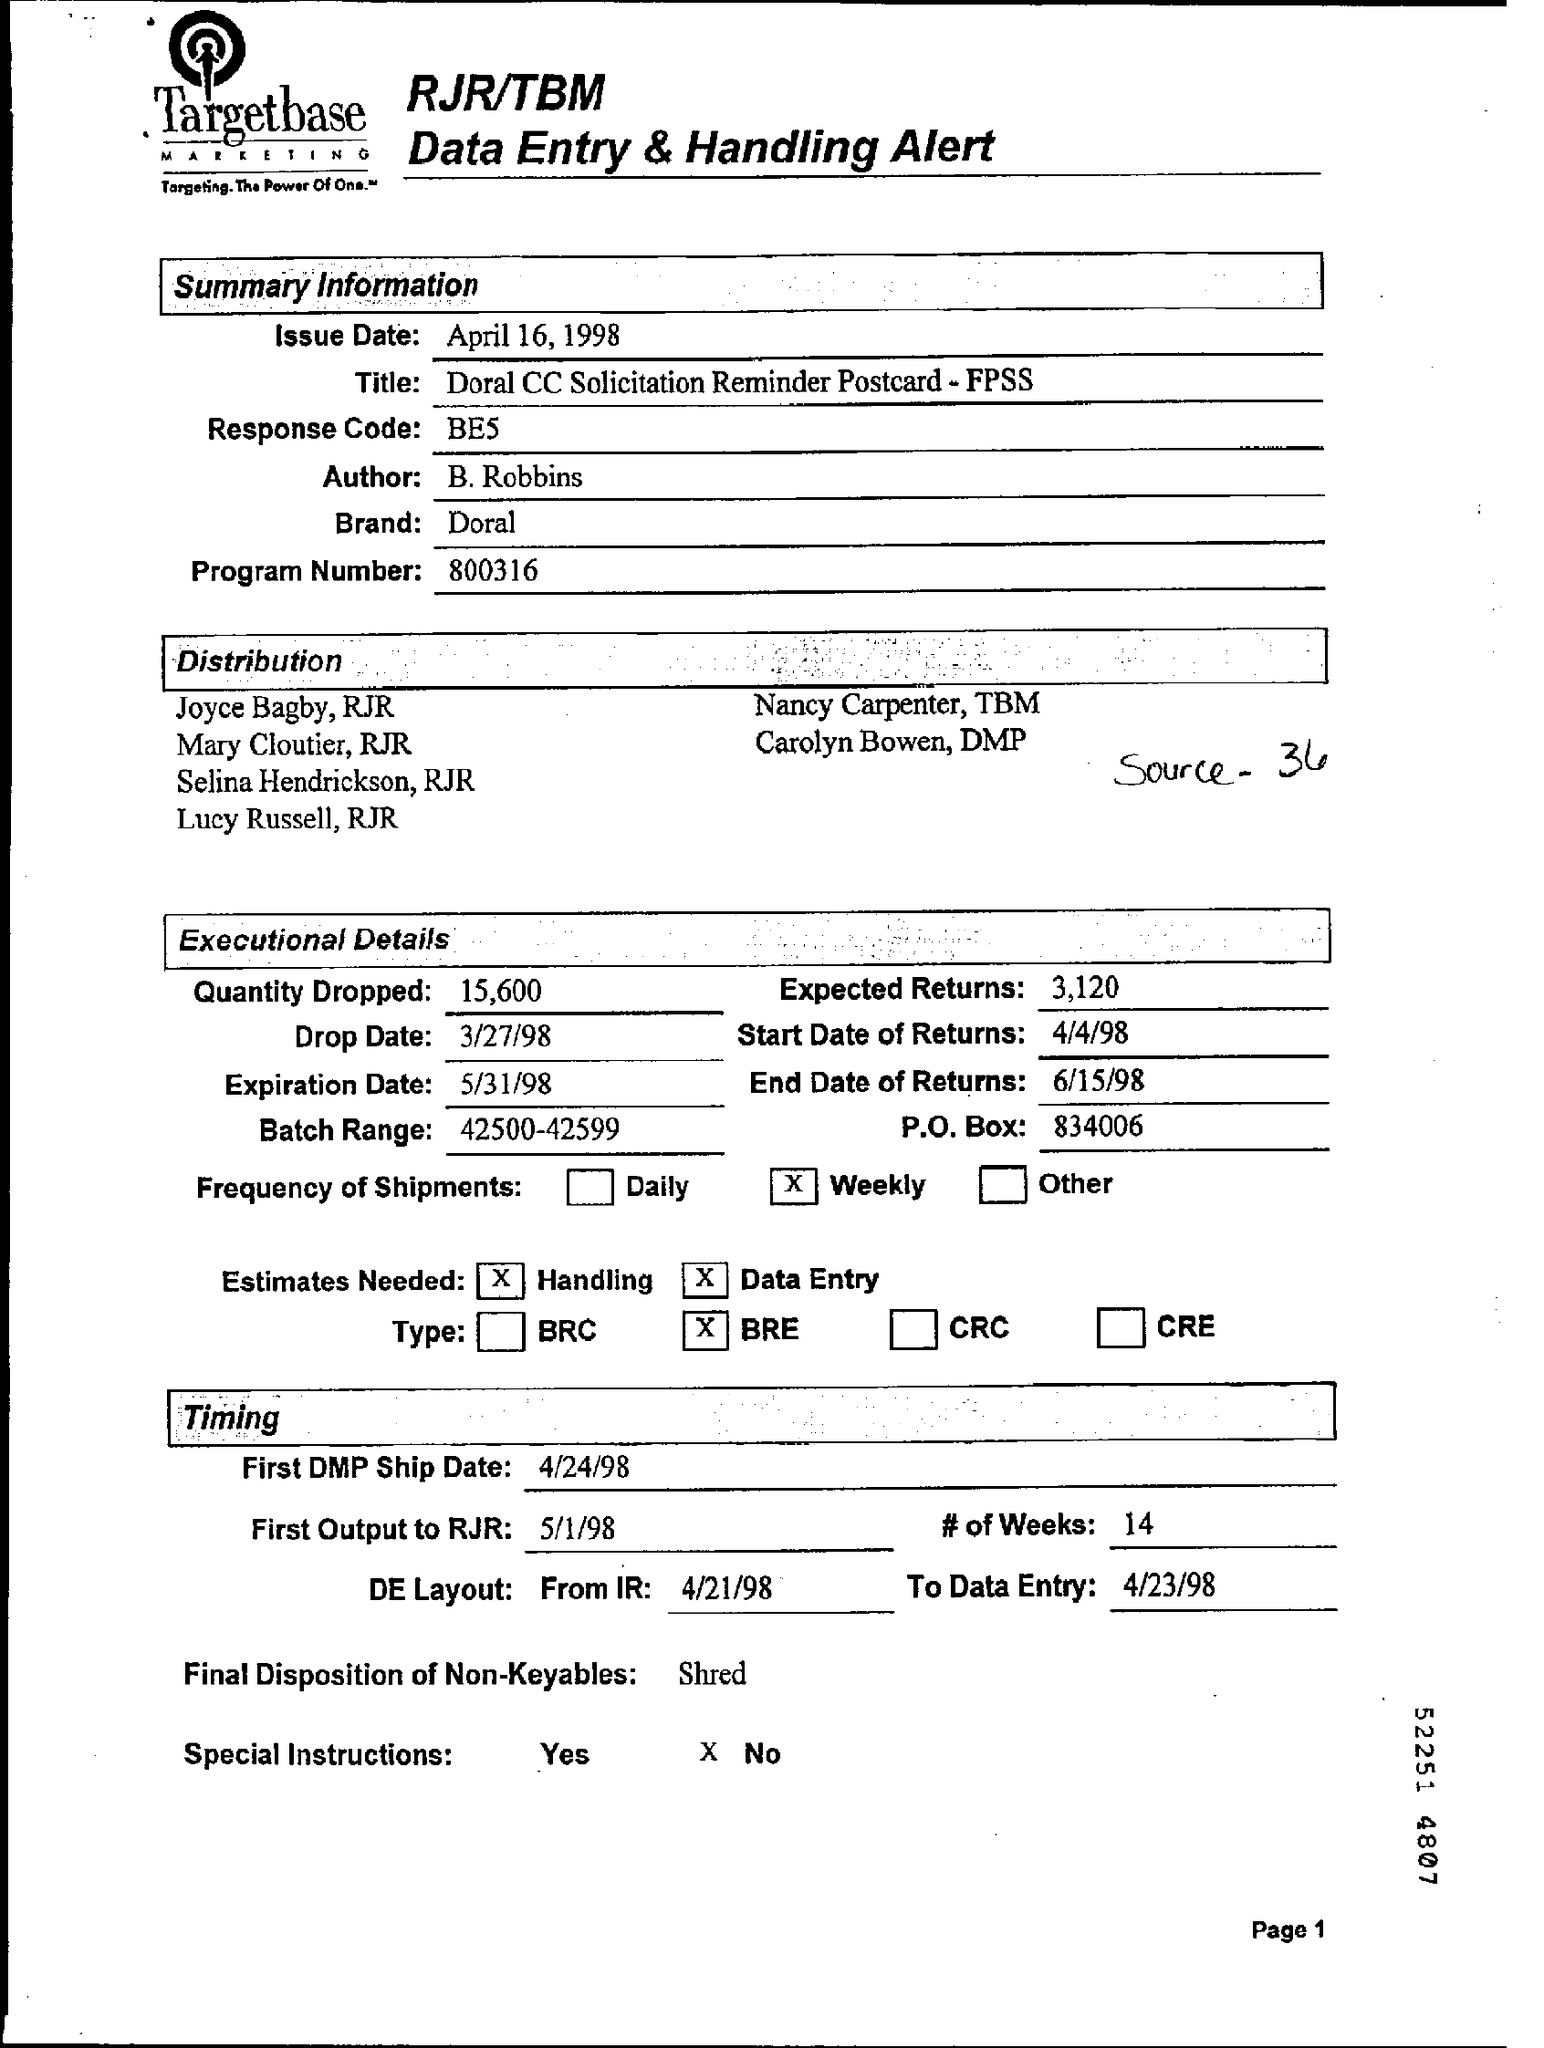What is the 'Title' ?
Ensure brevity in your answer.  Doral CC Solicitation Reminder Postcard - FPSS. What is the 'Response code' ?
Your answer should be compact. BE5. What is the program Number ?
Your answer should be compact. 800316. What is the quantity dropped ?
Provide a short and direct response. 15,600. What is the frequency of shipments ?
Your answer should be very brief. Weekly. What is the first DMP Ship Date ?
Give a very brief answer. 4/24/98. What is the batch Range?
Offer a terse response. 42500-42599. What is the End date of returns?
Ensure brevity in your answer.  6/15/98. 